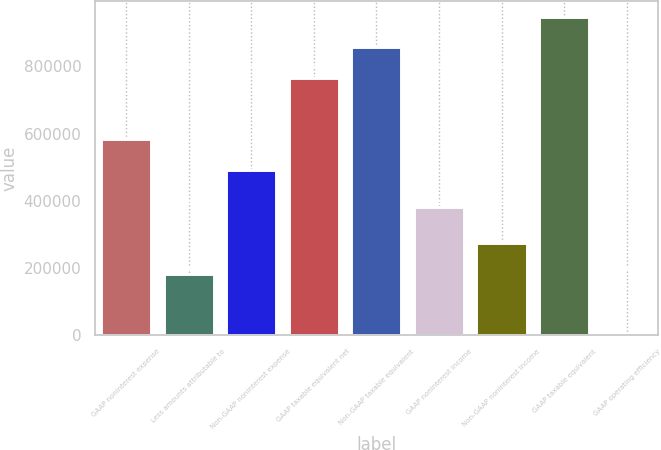<chart> <loc_0><loc_0><loc_500><loc_500><bar_chart><fcel>GAAP noninterest expense<fcel>Less amounts attributable to<fcel>Non-GAAP noninterest expense<fcel>GAAP taxable equivalent net<fcel>Non-GAAP taxable equivalent<fcel>GAAP noninterest income<fcel>Non-GAAP noninterest income<fcel>GAAP taxable equivalent<fcel>GAAP operating efficiency<nl><fcel>583234<fcel>182156<fcel>492184<fcel>765336<fcel>856386<fcel>382332<fcel>273206<fcel>947436<fcel>54.98<nl></chart> 